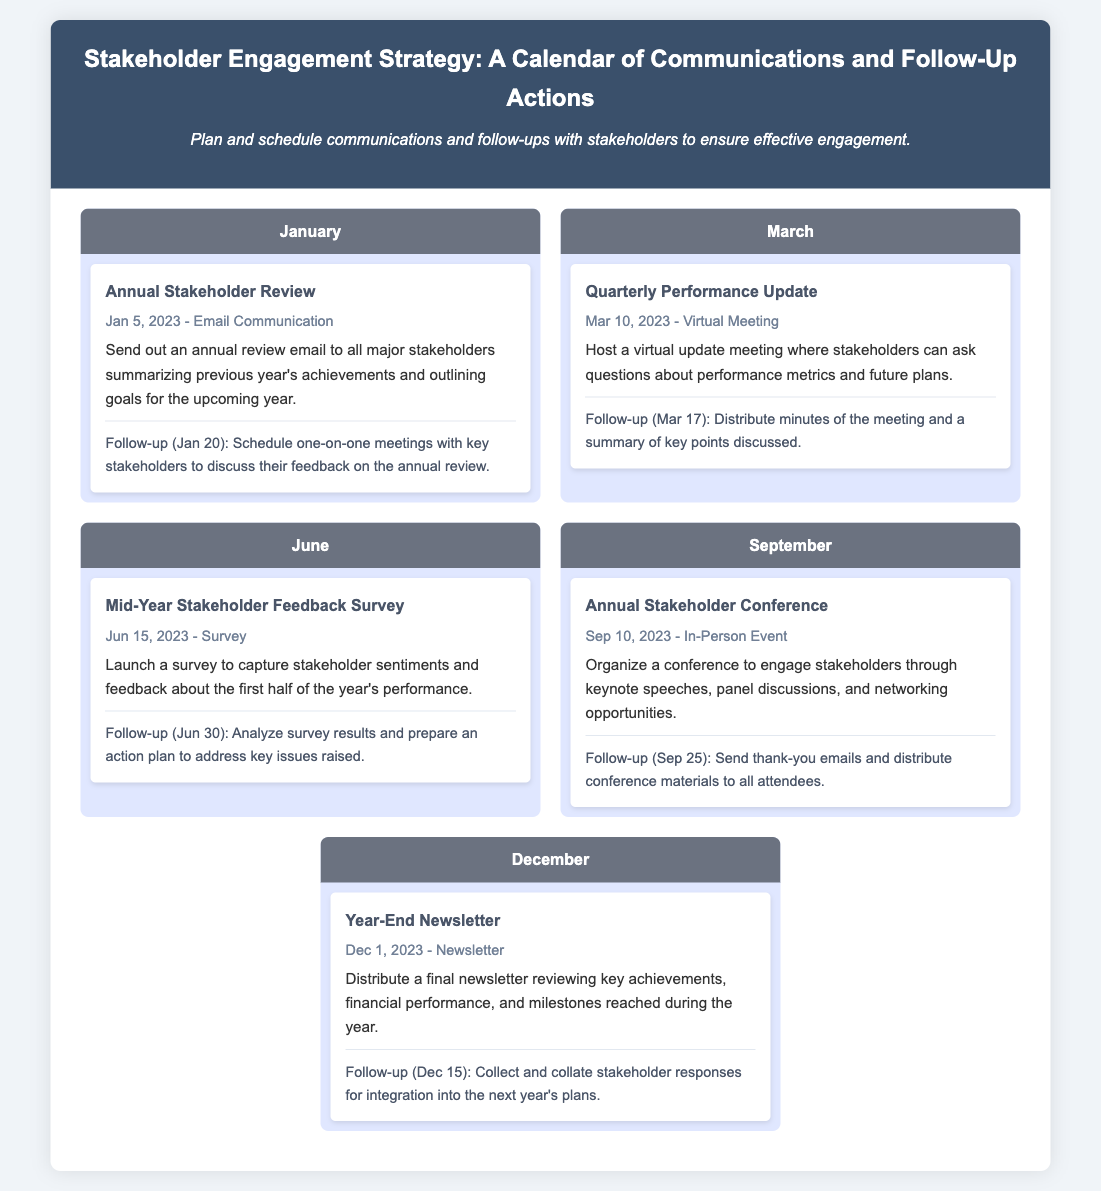what is the date of the Annual Stakeholder Review? The date of the Annual Stakeholder Review is given as Jan 5, 2023.
Answer: Jan 5, 2023 what type of communication is used for the Quarterly Performance Update? The type of communication for the Quarterly Performance Update is specified as a Virtual Meeting.
Answer: Virtual Meeting how many activities are listed in the month of September? The month of September contains one activity, which is the Annual Stakeholder Conference.
Answer: 1 what is the follow-up date for the Mid-Year Stakeholder Feedback Survey? The follow-up date for analyzing survey results is specified as Jun 30.
Answer: Jun 30 what is the main purpose of the Year-End Newsletter? The main purpose of the Year-End Newsletter is to review key achievements, financial performance, and milestones reached.
Answer: Review key achievements what type of event is planned for September? The planned event for September is categorized as an In-Person Event.
Answer: In-Person Event when is the follow-up for the Annual Stakeholder Review scheduled? The follow-up for the Annual Stakeholder Review is scheduled for Jan 20.
Answer: Jan 20 what is included in the follow-up after the Annual Stakeholder Conference? The follow-up includes sending thank-you emails and distributing conference materials.
Answer: Thank-you emails and conference materials how many months are represented in the calendar document? The calendar document represents five months from January to December.
Answer: Five months 